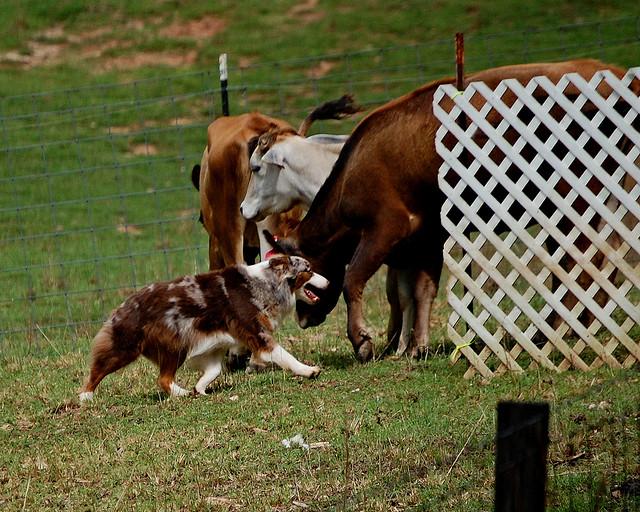What color is the fence?
Be succinct. White. What breed of dog is this?
Write a very short answer. Collie. Is this someone background?
Write a very short answer. No. 